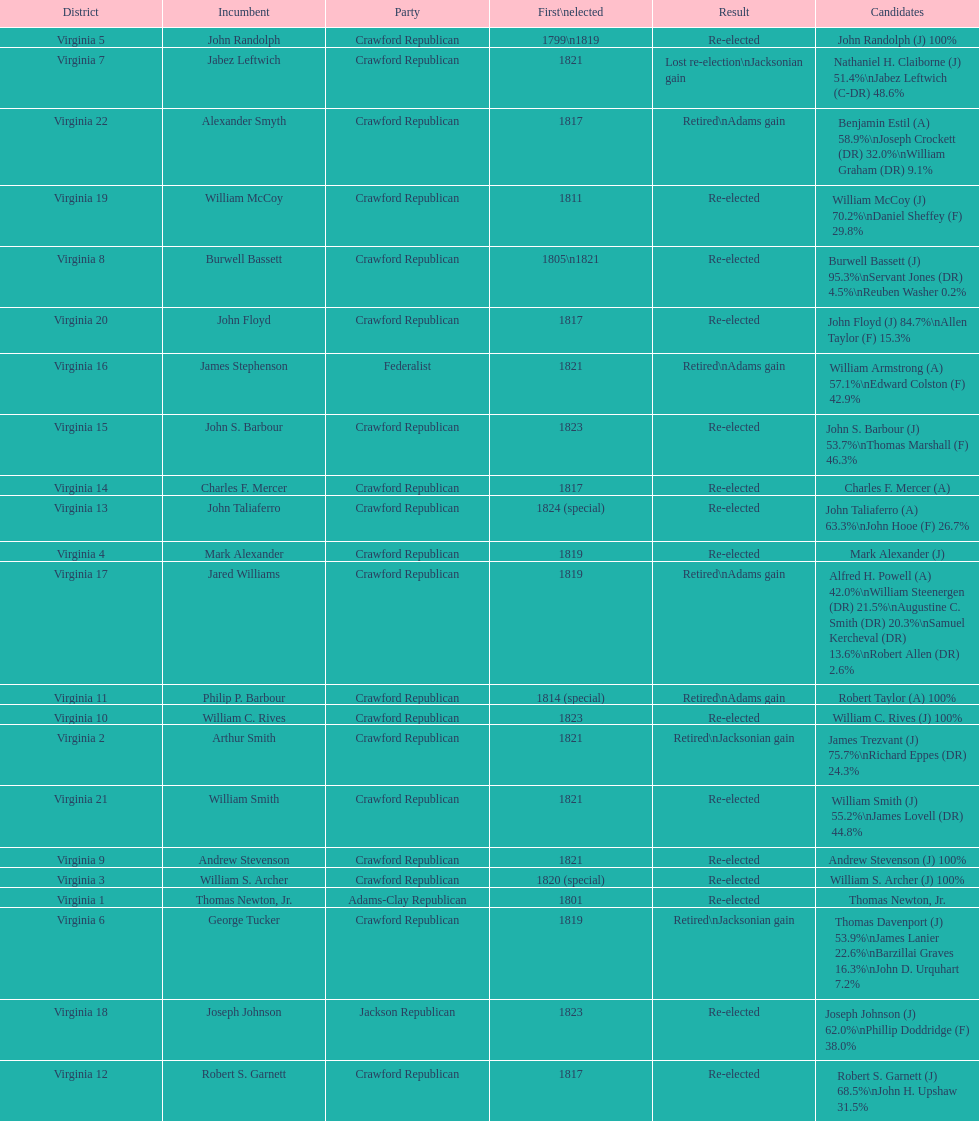Could you help me parse every detail presented in this table? {'header': ['District', 'Incumbent', 'Party', 'First\\nelected', 'Result', 'Candidates'], 'rows': [['Virginia 5', 'John Randolph', 'Crawford Republican', '1799\\n1819', 'Re-elected', 'John Randolph (J) 100%'], ['Virginia 7', 'Jabez Leftwich', 'Crawford Republican', '1821', 'Lost re-election\\nJacksonian gain', 'Nathaniel H. Claiborne (J) 51.4%\\nJabez Leftwich (C-DR) 48.6%'], ['Virginia 22', 'Alexander Smyth', 'Crawford Republican', '1817', 'Retired\\nAdams gain', 'Benjamin Estil (A) 58.9%\\nJoseph Crockett (DR) 32.0%\\nWilliam Graham (DR) 9.1%'], ['Virginia 19', 'William McCoy', 'Crawford Republican', '1811', 'Re-elected', 'William McCoy (J) 70.2%\\nDaniel Sheffey (F) 29.8%'], ['Virginia 8', 'Burwell Bassett', 'Crawford Republican', '1805\\n1821', 'Re-elected', 'Burwell Bassett (J) 95.3%\\nServant Jones (DR) 4.5%\\nReuben Washer 0.2%'], ['Virginia 20', 'John Floyd', 'Crawford Republican', '1817', 'Re-elected', 'John Floyd (J) 84.7%\\nAllen Taylor (F) 15.3%'], ['Virginia 16', 'James Stephenson', 'Federalist', '1821', 'Retired\\nAdams gain', 'William Armstrong (A) 57.1%\\nEdward Colston (F) 42.9%'], ['Virginia 15', 'John S. Barbour', 'Crawford Republican', '1823', 'Re-elected', 'John S. Barbour (J) 53.7%\\nThomas Marshall (F) 46.3%'], ['Virginia 14', 'Charles F. Mercer', 'Crawford Republican', '1817', 'Re-elected', 'Charles F. Mercer (A)'], ['Virginia 13', 'John Taliaferro', 'Crawford Republican', '1824 (special)', 'Re-elected', 'John Taliaferro (A) 63.3%\\nJohn Hooe (F) 26.7%'], ['Virginia 4', 'Mark Alexander', 'Crawford Republican', '1819', 'Re-elected', 'Mark Alexander (J)'], ['Virginia 17', 'Jared Williams', 'Crawford Republican', '1819', 'Retired\\nAdams gain', 'Alfred H. Powell (A) 42.0%\\nWilliam Steenergen (DR) 21.5%\\nAugustine C. Smith (DR) 20.3%\\nSamuel Kercheval (DR) 13.6%\\nRobert Allen (DR) 2.6%'], ['Virginia 11', 'Philip P. Barbour', 'Crawford Republican', '1814 (special)', 'Retired\\nAdams gain', 'Robert Taylor (A) 100%'], ['Virginia 10', 'William C. Rives', 'Crawford Republican', '1823', 'Re-elected', 'William C. Rives (J) 100%'], ['Virginia 2', 'Arthur Smith', 'Crawford Republican', '1821', 'Retired\\nJacksonian gain', 'James Trezvant (J) 75.7%\\nRichard Eppes (DR) 24.3%'], ['Virginia 21', 'William Smith', 'Crawford Republican', '1821', 'Re-elected', 'William Smith (J) 55.2%\\nJames Lovell (DR) 44.8%'], ['Virginia 9', 'Andrew Stevenson', 'Crawford Republican', '1821', 'Re-elected', 'Andrew Stevenson (J) 100%'], ['Virginia 3', 'William S. Archer', 'Crawford Republican', '1820 (special)', 'Re-elected', 'William S. Archer (J) 100%'], ['Virginia 1', 'Thomas Newton, Jr.', 'Adams-Clay Republican', '1801', 'Re-elected', 'Thomas Newton, Jr.'], ['Virginia 6', 'George Tucker', 'Crawford Republican', '1819', 'Retired\\nJacksonian gain', 'Thomas Davenport (J) 53.9%\\nJames Lanier 22.6%\\nBarzillai Graves 16.3%\\nJohn D. Urquhart 7.2%'], ['Virginia 18', 'Joseph Johnson', 'Jackson Republican', '1823', 'Re-elected', 'Joseph Johnson (J) 62.0%\\nPhillip Doddridge (F) 38.0%'], ['Virginia 12', 'Robert S. Garnett', 'Crawford Republican', '1817', 'Re-elected', 'Robert S. Garnett (J) 68.5%\\nJohn H. Upshaw 31.5%']]} Tell me the number of people first elected in 1817. 4. 